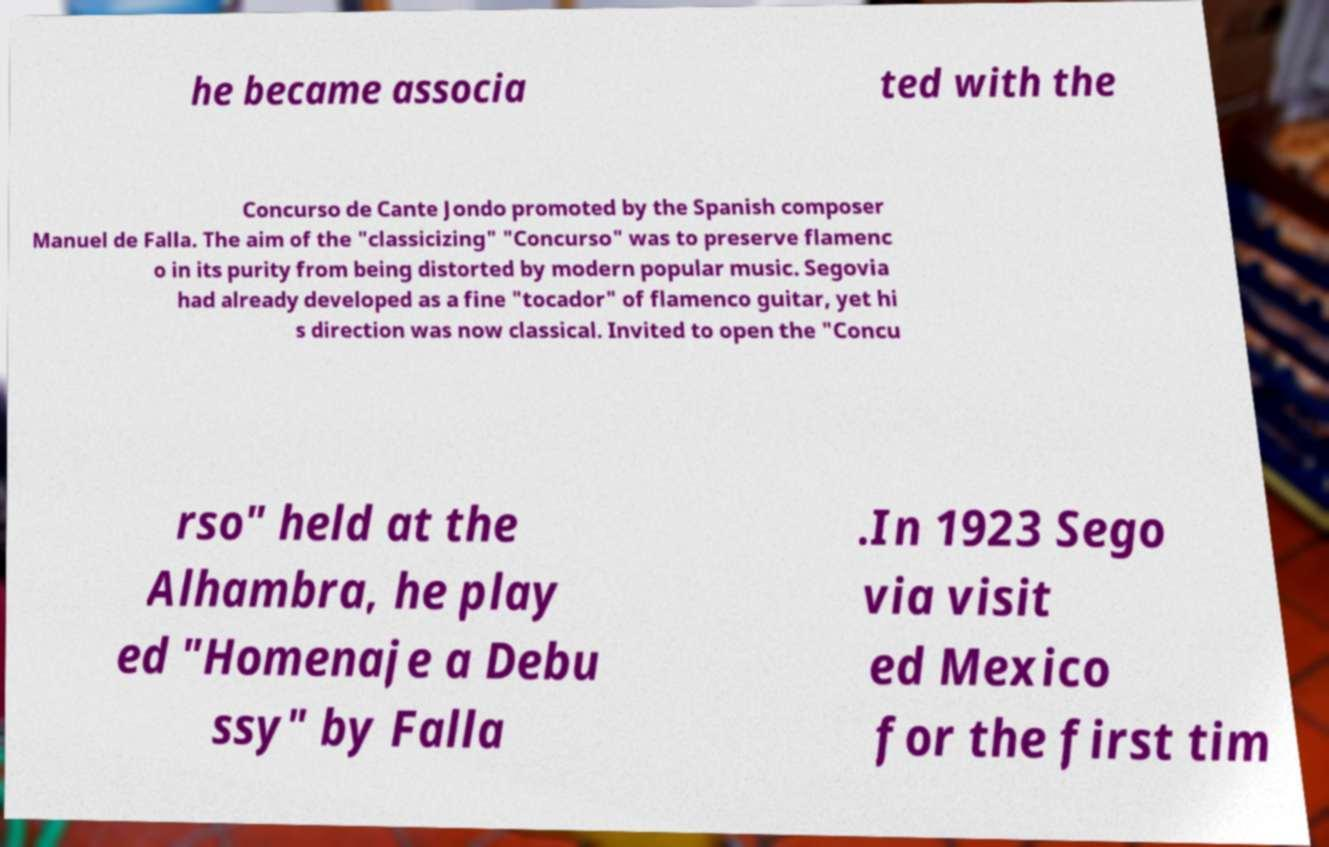For documentation purposes, I need the text within this image transcribed. Could you provide that? he became associa ted with the Concurso de Cante Jondo promoted by the Spanish composer Manuel de Falla. The aim of the "classicizing" "Concurso" was to preserve flamenc o in its purity from being distorted by modern popular music. Segovia had already developed as a fine "tocador" of flamenco guitar, yet hi s direction was now classical. Invited to open the "Concu rso" held at the Alhambra, he play ed "Homenaje a Debu ssy" by Falla .In 1923 Sego via visit ed Mexico for the first tim 